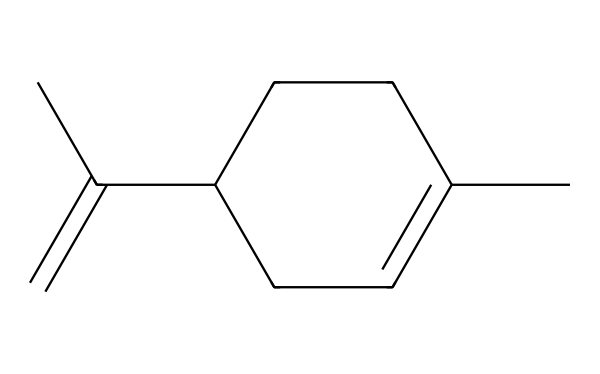how many carbon atoms are in limonene? The SMILES representation CC1=CCC(CC1)C(=C)C indicates the presence of carbon (C) atoms. Counting the carbon atoms in the structure yields 10 carbon atoms.
Answer: 10 what type of molecule is limonene? The chemical structure reveals multiple carbon-carbon bonds associated with organic compounds. This indicates that limonene is a hydrocarbon, specifically a terpene.
Answer: terpene how many double bonds are present in limonene? The SMILES notation shows a couple of "=" signs, which indicate the presence of double bonds. By analyzing the representation, there are two double bonds in the structure of limonene.
Answer: 2 is limonene aromatic? Aromatic compounds typically have conjugated pi bonds with resonance structures and a stable ring of carbon atoms. The structure provided indicates no such configuration in limonene; thus, it is not aromatic.
Answer: no what type of functional group is found in limonene? The presence of a double bond in the structure indicates that limonene contains a double bond (alkene) but there are no functional groups like alcohols or ketones present.
Answer: alkene what is the molecular formula for limonene? By using the carbon and hydrogen counts from the structure, the molecular formula can be derived. Counting gives 10 carbon atoms and 16 hydrogen atoms, leading to the formula C10H16.
Answer: C10H16 